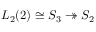<formula> <loc_0><loc_0><loc_500><loc_500>L _ { 2 } ( 2 ) \cong S _ { 3 } \twoheadrightarrow S _ { 2 }</formula> 